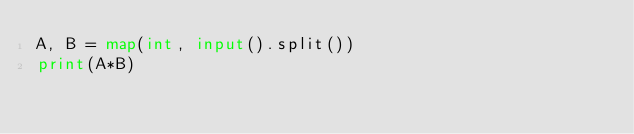Convert code to text. <code><loc_0><loc_0><loc_500><loc_500><_Python_>A, B = map(int, input().split())
print(A*B)</code> 